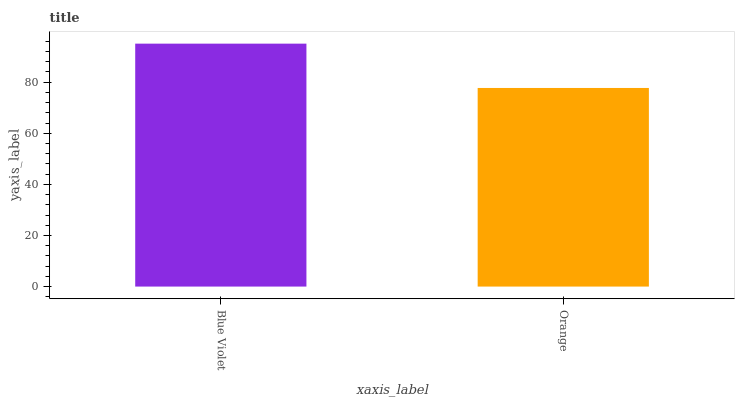Is Orange the minimum?
Answer yes or no. Yes. Is Blue Violet the maximum?
Answer yes or no. Yes. Is Orange the maximum?
Answer yes or no. No. Is Blue Violet greater than Orange?
Answer yes or no. Yes. Is Orange less than Blue Violet?
Answer yes or no. Yes. Is Orange greater than Blue Violet?
Answer yes or no. No. Is Blue Violet less than Orange?
Answer yes or no. No. Is Blue Violet the high median?
Answer yes or no. Yes. Is Orange the low median?
Answer yes or no. Yes. Is Orange the high median?
Answer yes or no. No. Is Blue Violet the low median?
Answer yes or no. No. 